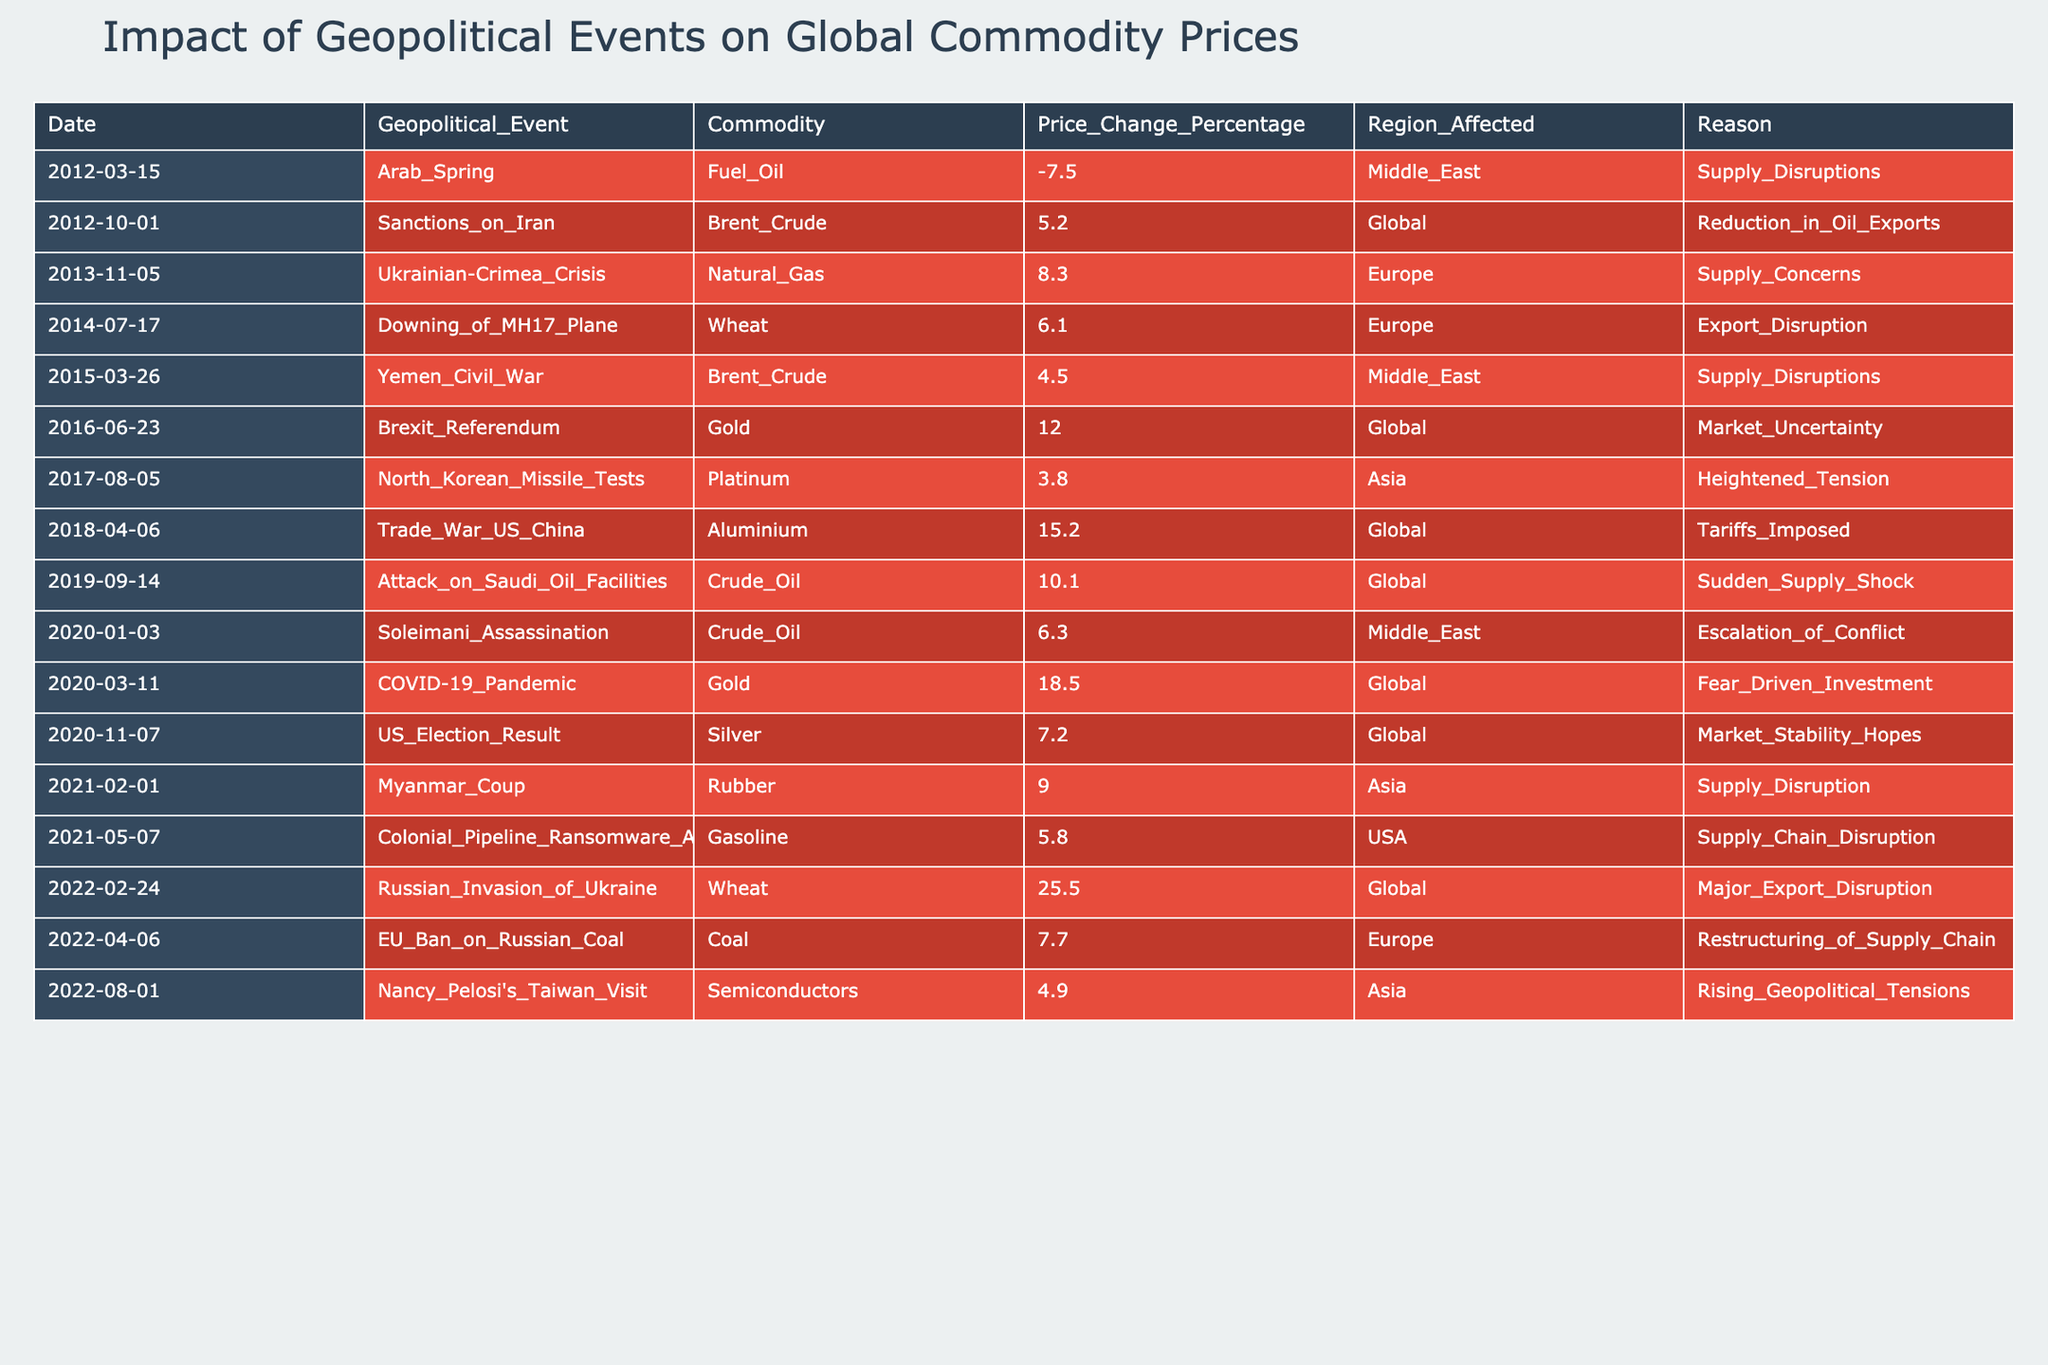What was the commodity that experienced the highest price change percentage due to the Russian invasion of Ukraine? Referring to the table, the event titled "Russian Invasion of Ukraine" shows a price change percentage of 25.5, which is higher than any other event listed. The corresponding commodity for this event is Wheat.
Answer: Wheat Which commodity had the largest price change in 2020? By examining the table, the year 2020 includes two events: the "Soleimani Assassination" with a price change of 6.3 for Crude Oil, and the "COVID-19 Pandemic" which had a price change of 18.5 for Gold. The highest change among these is 18.5 for Gold.
Answer: Gold How many geopolitical events affected the price of Crude Oil in the dataset? The table features two events associated with Crude Oil: the "Sanctions on Iran" with a change of 5.2 and the "Attack on Saudi Oil Facilities" with a change of 10.1. Therefore, there are two distinct events impacting Crude Oil.
Answer: 2 Was the price change for Gold higher during the Brexit Referendum or the COVID-19 Pandemic? The Brexit Referendum shows a price change of 12.0 for Gold, while the COVID-19 Pandemic shows a higher price change of 18.5. Since 18.5 is greater than 12.0, the COVID-19 Pandemic led to a higher price change for Gold.
Answer: Yes What is the average price change percentage for the commodities affected in Asia? The table indicates the following price changes for commodities in Asia: 3.8 for Platinum and 9.0 for Rubber. To find the average, we sum these: 3.8 + 9.0 = 12.8 and divide by 2 (since there are 2 events), resulting in an average of 12.8 / 2 = 6.4.
Answer: 6.4 How many events directly affected regions classified as "Global"? The table shows six events categorized under "Global": "Sanctions on Iran," "Brexit Referendum," "Trade War US China," "Attack on Saudi Oil Facilities," "COVID-19 Pandemic," and "US Election Result." Therefore, there are six events affecting "Global" regions.
Answer: 6 Which event caused the most significant drop in Fuel Oil prices, and what was the percentage change? The table lists the "Arab Spring" with a price change percentage of -7.5 for Fuel Oil as the only event affecting this commodity. Since it’s the only instance, it represents the largest drop.
Answer: Arab Spring, -7.5 Is it true that the Yemeni Civil War caused a price surge in Brent Crude? The price change for Brent Crude during the Yemen Civil War is listed as 4.5. A price change of 4.5 indicates a surge, meaning it is true that this event caused a price increase.
Answer: Yes 